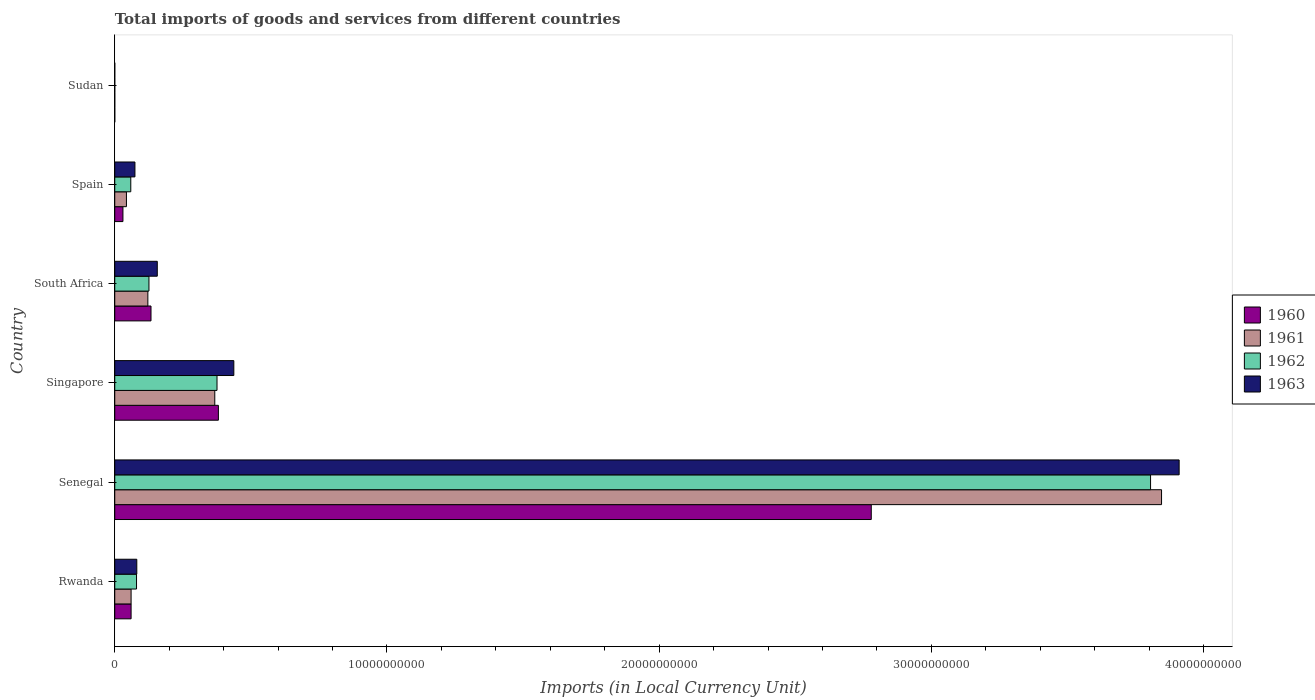How many different coloured bars are there?
Keep it short and to the point. 4. How many groups of bars are there?
Ensure brevity in your answer.  6. Are the number of bars per tick equal to the number of legend labels?
Make the answer very short. Yes. How many bars are there on the 4th tick from the top?
Keep it short and to the point. 4. What is the label of the 4th group of bars from the top?
Your answer should be compact. Singapore. In how many cases, is the number of bars for a given country not equal to the number of legend labels?
Your answer should be compact. 0. What is the Amount of goods and services imports in 1963 in Sudan?
Give a very brief answer. 8.49e+04. Across all countries, what is the maximum Amount of goods and services imports in 1963?
Your response must be concise. 3.91e+1. Across all countries, what is the minimum Amount of goods and services imports in 1963?
Ensure brevity in your answer.  8.49e+04. In which country was the Amount of goods and services imports in 1963 maximum?
Your answer should be very brief. Senegal. In which country was the Amount of goods and services imports in 1963 minimum?
Your answer should be very brief. Sudan. What is the total Amount of goods and services imports in 1962 in the graph?
Give a very brief answer. 4.45e+1. What is the difference between the Amount of goods and services imports in 1963 in Singapore and that in Sudan?
Your answer should be compact. 4.37e+09. What is the difference between the Amount of goods and services imports in 1962 in Rwanda and the Amount of goods and services imports in 1963 in Spain?
Your answer should be very brief. 5.85e+07. What is the average Amount of goods and services imports in 1962 per country?
Offer a terse response. 7.41e+09. What is the difference between the Amount of goods and services imports in 1963 and Amount of goods and services imports in 1962 in South Africa?
Give a very brief answer. 3.06e+08. In how many countries, is the Amount of goods and services imports in 1960 greater than 24000000000 LCU?
Provide a short and direct response. 1. What is the ratio of the Amount of goods and services imports in 1962 in Senegal to that in Spain?
Ensure brevity in your answer.  64.62. Is the difference between the Amount of goods and services imports in 1963 in Rwanda and South Africa greater than the difference between the Amount of goods and services imports in 1962 in Rwanda and South Africa?
Offer a terse response. No. What is the difference between the highest and the second highest Amount of goods and services imports in 1962?
Your answer should be compact. 3.43e+1. What is the difference between the highest and the lowest Amount of goods and services imports in 1961?
Make the answer very short. 3.85e+1. In how many countries, is the Amount of goods and services imports in 1961 greater than the average Amount of goods and services imports in 1961 taken over all countries?
Ensure brevity in your answer.  1. What does the 2nd bar from the bottom in Singapore represents?
Offer a terse response. 1961. How many bars are there?
Ensure brevity in your answer.  24. How many countries are there in the graph?
Your answer should be compact. 6. Does the graph contain any zero values?
Keep it short and to the point. No. Where does the legend appear in the graph?
Your answer should be very brief. Center right. How many legend labels are there?
Your answer should be compact. 4. What is the title of the graph?
Your response must be concise. Total imports of goods and services from different countries. Does "1961" appear as one of the legend labels in the graph?
Your answer should be compact. Yes. What is the label or title of the X-axis?
Your response must be concise. Imports (in Local Currency Unit). What is the label or title of the Y-axis?
Offer a terse response. Country. What is the Imports (in Local Currency Unit) of 1960 in Rwanda?
Your response must be concise. 6.00e+08. What is the Imports (in Local Currency Unit) of 1961 in Rwanda?
Keep it short and to the point. 6.00e+08. What is the Imports (in Local Currency Unit) of 1962 in Rwanda?
Provide a short and direct response. 8.00e+08. What is the Imports (in Local Currency Unit) in 1963 in Rwanda?
Your answer should be very brief. 8.10e+08. What is the Imports (in Local Currency Unit) in 1960 in Senegal?
Provide a short and direct response. 2.78e+1. What is the Imports (in Local Currency Unit) in 1961 in Senegal?
Provide a succinct answer. 3.85e+1. What is the Imports (in Local Currency Unit) in 1962 in Senegal?
Your response must be concise. 3.81e+1. What is the Imports (in Local Currency Unit) of 1963 in Senegal?
Give a very brief answer. 3.91e+1. What is the Imports (in Local Currency Unit) of 1960 in Singapore?
Ensure brevity in your answer.  3.81e+09. What is the Imports (in Local Currency Unit) in 1961 in Singapore?
Keep it short and to the point. 3.67e+09. What is the Imports (in Local Currency Unit) in 1962 in Singapore?
Your answer should be very brief. 3.76e+09. What is the Imports (in Local Currency Unit) of 1963 in Singapore?
Give a very brief answer. 4.37e+09. What is the Imports (in Local Currency Unit) of 1960 in South Africa?
Provide a short and direct response. 1.33e+09. What is the Imports (in Local Currency Unit) in 1961 in South Africa?
Provide a short and direct response. 1.22e+09. What is the Imports (in Local Currency Unit) in 1962 in South Africa?
Keep it short and to the point. 1.26e+09. What is the Imports (in Local Currency Unit) of 1963 in South Africa?
Your answer should be compact. 1.56e+09. What is the Imports (in Local Currency Unit) of 1960 in Spain?
Make the answer very short. 3.00e+08. What is the Imports (in Local Currency Unit) of 1961 in Spain?
Ensure brevity in your answer.  4.29e+08. What is the Imports (in Local Currency Unit) of 1962 in Spain?
Provide a succinct answer. 5.89e+08. What is the Imports (in Local Currency Unit) of 1963 in Spain?
Offer a very short reply. 7.42e+08. What is the Imports (in Local Currency Unit) in 1960 in Sudan?
Your answer should be compact. 5.10e+04. What is the Imports (in Local Currency Unit) of 1961 in Sudan?
Provide a short and direct response. 6.11e+04. What is the Imports (in Local Currency Unit) in 1962 in Sudan?
Your response must be concise. 6.96e+04. What is the Imports (in Local Currency Unit) of 1963 in Sudan?
Your answer should be very brief. 8.49e+04. Across all countries, what is the maximum Imports (in Local Currency Unit) of 1960?
Your answer should be very brief. 2.78e+1. Across all countries, what is the maximum Imports (in Local Currency Unit) of 1961?
Offer a terse response. 3.85e+1. Across all countries, what is the maximum Imports (in Local Currency Unit) of 1962?
Your response must be concise. 3.81e+1. Across all countries, what is the maximum Imports (in Local Currency Unit) of 1963?
Give a very brief answer. 3.91e+1. Across all countries, what is the minimum Imports (in Local Currency Unit) in 1960?
Your response must be concise. 5.10e+04. Across all countries, what is the minimum Imports (in Local Currency Unit) of 1961?
Offer a very short reply. 6.11e+04. Across all countries, what is the minimum Imports (in Local Currency Unit) of 1962?
Provide a succinct answer. 6.96e+04. Across all countries, what is the minimum Imports (in Local Currency Unit) in 1963?
Your response must be concise. 8.49e+04. What is the total Imports (in Local Currency Unit) in 1960 in the graph?
Offer a terse response. 3.38e+1. What is the total Imports (in Local Currency Unit) of 1961 in the graph?
Offer a terse response. 4.44e+1. What is the total Imports (in Local Currency Unit) of 1962 in the graph?
Your response must be concise. 4.45e+1. What is the total Imports (in Local Currency Unit) in 1963 in the graph?
Your answer should be very brief. 4.66e+1. What is the difference between the Imports (in Local Currency Unit) of 1960 in Rwanda and that in Senegal?
Provide a succinct answer. -2.72e+1. What is the difference between the Imports (in Local Currency Unit) in 1961 in Rwanda and that in Senegal?
Provide a succinct answer. -3.79e+1. What is the difference between the Imports (in Local Currency Unit) in 1962 in Rwanda and that in Senegal?
Ensure brevity in your answer.  -3.73e+1. What is the difference between the Imports (in Local Currency Unit) in 1963 in Rwanda and that in Senegal?
Your answer should be compact. -3.83e+1. What is the difference between the Imports (in Local Currency Unit) in 1960 in Rwanda and that in Singapore?
Make the answer very short. -3.21e+09. What is the difference between the Imports (in Local Currency Unit) in 1961 in Rwanda and that in Singapore?
Provide a succinct answer. -3.07e+09. What is the difference between the Imports (in Local Currency Unit) of 1962 in Rwanda and that in Singapore?
Offer a very short reply. -2.96e+09. What is the difference between the Imports (in Local Currency Unit) of 1963 in Rwanda and that in Singapore?
Offer a terse response. -3.56e+09. What is the difference between the Imports (in Local Currency Unit) of 1960 in Rwanda and that in South Africa?
Keep it short and to the point. -7.32e+08. What is the difference between the Imports (in Local Currency Unit) of 1961 in Rwanda and that in South Africa?
Your answer should be compact. -6.16e+08. What is the difference between the Imports (in Local Currency Unit) in 1962 in Rwanda and that in South Africa?
Your response must be concise. -4.57e+08. What is the difference between the Imports (in Local Currency Unit) of 1963 in Rwanda and that in South Africa?
Give a very brief answer. -7.52e+08. What is the difference between the Imports (in Local Currency Unit) of 1960 in Rwanda and that in Spain?
Provide a succinct answer. 3.00e+08. What is the difference between the Imports (in Local Currency Unit) of 1961 in Rwanda and that in Spain?
Your response must be concise. 1.71e+08. What is the difference between the Imports (in Local Currency Unit) of 1962 in Rwanda and that in Spain?
Give a very brief answer. 2.11e+08. What is the difference between the Imports (in Local Currency Unit) in 1963 in Rwanda and that in Spain?
Provide a succinct answer. 6.85e+07. What is the difference between the Imports (in Local Currency Unit) in 1960 in Rwanda and that in Sudan?
Offer a terse response. 6.00e+08. What is the difference between the Imports (in Local Currency Unit) in 1961 in Rwanda and that in Sudan?
Provide a succinct answer. 6.00e+08. What is the difference between the Imports (in Local Currency Unit) in 1962 in Rwanda and that in Sudan?
Your response must be concise. 8.00e+08. What is the difference between the Imports (in Local Currency Unit) of 1963 in Rwanda and that in Sudan?
Offer a very short reply. 8.10e+08. What is the difference between the Imports (in Local Currency Unit) in 1960 in Senegal and that in Singapore?
Give a very brief answer. 2.40e+1. What is the difference between the Imports (in Local Currency Unit) in 1961 in Senegal and that in Singapore?
Provide a short and direct response. 3.48e+1. What is the difference between the Imports (in Local Currency Unit) of 1962 in Senegal and that in Singapore?
Ensure brevity in your answer.  3.43e+1. What is the difference between the Imports (in Local Currency Unit) of 1963 in Senegal and that in Singapore?
Your answer should be very brief. 3.47e+1. What is the difference between the Imports (in Local Currency Unit) of 1960 in Senegal and that in South Africa?
Your answer should be compact. 2.65e+1. What is the difference between the Imports (in Local Currency Unit) in 1961 in Senegal and that in South Africa?
Make the answer very short. 3.72e+1. What is the difference between the Imports (in Local Currency Unit) in 1962 in Senegal and that in South Africa?
Keep it short and to the point. 3.68e+1. What is the difference between the Imports (in Local Currency Unit) in 1963 in Senegal and that in South Africa?
Make the answer very short. 3.75e+1. What is the difference between the Imports (in Local Currency Unit) of 1960 in Senegal and that in Spain?
Your response must be concise. 2.75e+1. What is the difference between the Imports (in Local Currency Unit) of 1961 in Senegal and that in Spain?
Ensure brevity in your answer.  3.80e+1. What is the difference between the Imports (in Local Currency Unit) in 1962 in Senegal and that in Spain?
Your answer should be compact. 3.75e+1. What is the difference between the Imports (in Local Currency Unit) of 1963 in Senegal and that in Spain?
Provide a succinct answer. 3.84e+1. What is the difference between the Imports (in Local Currency Unit) in 1960 in Senegal and that in Sudan?
Keep it short and to the point. 2.78e+1. What is the difference between the Imports (in Local Currency Unit) of 1961 in Senegal and that in Sudan?
Offer a very short reply. 3.85e+1. What is the difference between the Imports (in Local Currency Unit) in 1962 in Senegal and that in Sudan?
Ensure brevity in your answer.  3.81e+1. What is the difference between the Imports (in Local Currency Unit) of 1963 in Senegal and that in Sudan?
Give a very brief answer. 3.91e+1. What is the difference between the Imports (in Local Currency Unit) of 1960 in Singapore and that in South Africa?
Your answer should be very brief. 2.48e+09. What is the difference between the Imports (in Local Currency Unit) in 1961 in Singapore and that in South Africa?
Keep it short and to the point. 2.46e+09. What is the difference between the Imports (in Local Currency Unit) in 1962 in Singapore and that in South Africa?
Offer a terse response. 2.50e+09. What is the difference between the Imports (in Local Currency Unit) in 1963 in Singapore and that in South Africa?
Your answer should be compact. 2.81e+09. What is the difference between the Imports (in Local Currency Unit) in 1960 in Singapore and that in Spain?
Give a very brief answer. 3.51e+09. What is the difference between the Imports (in Local Currency Unit) in 1961 in Singapore and that in Spain?
Your answer should be very brief. 3.25e+09. What is the difference between the Imports (in Local Currency Unit) in 1962 in Singapore and that in Spain?
Your response must be concise. 3.17e+09. What is the difference between the Imports (in Local Currency Unit) in 1963 in Singapore and that in Spain?
Offer a terse response. 3.63e+09. What is the difference between the Imports (in Local Currency Unit) in 1960 in Singapore and that in Sudan?
Give a very brief answer. 3.81e+09. What is the difference between the Imports (in Local Currency Unit) of 1961 in Singapore and that in Sudan?
Your answer should be compact. 3.67e+09. What is the difference between the Imports (in Local Currency Unit) in 1962 in Singapore and that in Sudan?
Your answer should be compact. 3.76e+09. What is the difference between the Imports (in Local Currency Unit) of 1963 in Singapore and that in Sudan?
Provide a short and direct response. 4.37e+09. What is the difference between the Imports (in Local Currency Unit) in 1960 in South Africa and that in Spain?
Ensure brevity in your answer.  1.03e+09. What is the difference between the Imports (in Local Currency Unit) in 1961 in South Africa and that in Spain?
Keep it short and to the point. 7.87e+08. What is the difference between the Imports (in Local Currency Unit) of 1962 in South Africa and that in Spain?
Your response must be concise. 6.68e+08. What is the difference between the Imports (in Local Currency Unit) in 1963 in South Africa and that in Spain?
Ensure brevity in your answer.  8.21e+08. What is the difference between the Imports (in Local Currency Unit) of 1960 in South Africa and that in Sudan?
Provide a short and direct response. 1.33e+09. What is the difference between the Imports (in Local Currency Unit) of 1961 in South Africa and that in Sudan?
Provide a short and direct response. 1.22e+09. What is the difference between the Imports (in Local Currency Unit) in 1962 in South Africa and that in Sudan?
Your answer should be very brief. 1.26e+09. What is the difference between the Imports (in Local Currency Unit) in 1963 in South Africa and that in Sudan?
Offer a terse response. 1.56e+09. What is the difference between the Imports (in Local Currency Unit) in 1960 in Spain and that in Sudan?
Make the answer very short. 3.00e+08. What is the difference between the Imports (in Local Currency Unit) of 1961 in Spain and that in Sudan?
Make the answer very short. 4.29e+08. What is the difference between the Imports (in Local Currency Unit) of 1962 in Spain and that in Sudan?
Provide a succinct answer. 5.89e+08. What is the difference between the Imports (in Local Currency Unit) of 1963 in Spain and that in Sudan?
Make the answer very short. 7.41e+08. What is the difference between the Imports (in Local Currency Unit) in 1960 in Rwanda and the Imports (in Local Currency Unit) in 1961 in Senegal?
Your answer should be very brief. -3.79e+1. What is the difference between the Imports (in Local Currency Unit) of 1960 in Rwanda and the Imports (in Local Currency Unit) of 1962 in Senegal?
Provide a short and direct response. -3.75e+1. What is the difference between the Imports (in Local Currency Unit) in 1960 in Rwanda and the Imports (in Local Currency Unit) in 1963 in Senegal?
Your response must be concise. -3.85e+1. What is the difference between the Imports (in Local Currency Unit) of 1961 in Rwanda and the Imports (in Local Currency Unit) of 1962 in Senegal?
Your answer should be very brief. -3.75e+1. What is the difference between the Imports (in Local Currency Unit) of 1961 in Rwanda and the Imports (in Local Currency Unit) of 1963 in Senegal?
Ensure brevity in your answer.  -3.85e+1. What is the difference between the Imports (in Local Currency Unit) of 1962 in Rwanda and the Imports (in Local Currency Unit) of 1963 in Senegal?
Make the answer very short. -3.83e+1. What is the difference between the Imports (in Local Currency Unit) in 1960 in Rwanda and the Imports (in Local Currency Unit) in 1961 in Singapore?
Offer a terse response. -3.07e+09. What is the difference between the Imports (in Local Currency Unit) in 1960 in Rwanda and the Imports (in Local Currency Unit) in 1962 in Singapore?
Ensure brevity in your answer.  -3.16e+09. What is the difference between the Imports (in Local Currency Unit) in 1960 in Rwanda and the Imports (in Local Currency Unit) in 1963 in Singapore?
Provide a succinct answer. -3.77e+09. What is the difference between the Imports (in Local Currency Unit) in 1961 in Rwanda and the Imports (in Local Currency Unit) in 1962 in Singapore?
Offer a very short reply. -3.16e+09. What is the difference between the Imports (in Local Currency Unit) in 1961 in Rwanda and the Imports (in Local Currency Unit) in 1963 in Singapore?
Offer a terse response. -3.77e+09. What is the difference between the Imports (in Local Currency Unit) of 1962 in Rwanda and the Imports (in Local Currency Unit) of 1963 in Singapore?
Offer a very short reply. -3.57e+09. What is the difference between the Imports (in Local Currency Unit) of 1960 in Rwanda and the Imports (in Local Currency Unit) of 1961 in South Africa?
Ensure brevity in your answer.  -6.16e+08. What is the difference between the Imports (in Local Currency Unit) in 1960 in Rwanda and the Imports (in Local Currency Unit) in 1962 in South Africa?
Make the answer very short. -6.57e+08. What is the difference between the Imports (in Local Currency Unit) of 1960 in Rwanda and the Imports (in Local Currency Unit) of 1963 in South Africa?
Provide a succinct answer. -9.62e+08. What is the difference between the Imports (in Local Currency Unit) of 1961 in Rwanda and the Imports (in Local Currency Unit) of 1962 in South Africa?
Provide a short and direct response. -6.57e+08. What is the difference between the Imports (in Local Currency Unit) in 1961 in Rwanda and the Imports (in Local Currency Unit) in 1963 in South Africa?
Offer a very short reply. -9.62e+08. What is the difference between the Imports (in Local Currency Unit) in 1962 in Rwanda and the Imports (in Local Currency Unit) in 1963 in South Africa?
Your answer should be compact. -7.62e+08. What is the difference between the Imports (in Local Currency Unit) of 1960 in Rwanda and the Imports (in Local Currency Unit) of 1961 in Spain?
Provide a succinct answer. 1.71e+08. What is the difference between the Imports (in Local Currency Unit) in 1960 in Rwanda and the Imports (in Local Currency Unit) in 1962 in Spain?
Provide a succinct answer. 1.11e+07. What is the difference between the Imports (in Local Currency Unit) in 1960 in Rwanda and the Imports (in Local Currency Unit) in 1963 in Spain?
Your response must be concise. -1.42e+08. What is the difference between the Imports (in Local Currency Unit) of 1961 in Rwanda and the Imports (in Local Currency Unit) of 1962 in Spain?
Provide a succinct answer. 1.11e+07. What is the difference between the Imports (in Local Currency Unit) in 1961 in Rwanda and the Imports (in Local Currency Unit) in 1963 in Spain?
Offer a terse response. -1.42e+08. What is the difference between the Imports (in Local Currency Unit) of 1962 in Rwanda and the Imports (in Local Currency Unit) of 1963 in Spain?
Provide a short and direct response. 5.85e+07. What is the difference between the Imports (in Local Currency Unit) of 1960 in Rwanda and the Imports (in Local Currency Unit) of 1961 in Sudan?
Give a very brief answer. 6.00e+08. What is the difference between the Imports (in Local Currency Unit) in 1960 in Rwanda and the Imports (in Local Currency Unit) in 1962 in Sudan?
Your response must be concise. 6.00e+08. What is the difference between the Imports (in Local Currency Unit) in 1960 in Rwanda and the Imports (in Local Currency Unit) in 1963 in Sudan?
Provide a short and direct response. 6.00e+08. What is the difference between the Imports (in Local Currency Unit) in 1961 in Rwanda and the Imports (in Local Currency Unit) in 1962 in Sudan?
Offer a terse response. 6.00e+08. What is the difference between the Imports (in Local Currency Unit) in 1961 in Rwanda and the Imports (in Local Currency Unit) in 1963 in Sudan?
Offer a terse response. 6.00e+08. What is the difference between the Imports (in Local Currency Unit) of 1962 in Rwanda and the Imports (in Local Currency Unit) of 1963 in Sudan?
Provide a short and direct response. 8.00e+08. What is the difference between the Imports (in Local Currency Unit) of 1960 in Senegal and the Imports (in Local Currency Unit) of 1961 in Singapore?
Your response must be concise. 2.41e+1. What is the difference between the Imports (in Local Currency Unit) in 1960 in Senegal and the Imports (in Local Currency Unit) in 1962 in Singapore?
Your answer should be very brief. 2.40e+1. What is the difference between the Imports (in Local Currency Unit) in 1960 in Senegal and the Imports (in Local Currency Unit) in 1963 in Singapore?
Provide a short and direct response. 2.34e+1. What is the difference between the Imports (in Local Currency Unit) of 1961 in Senegal and the Imports (in Local Currency Unit) of 1962 in Singapore?
Offer a very short reply. 3.47e+1. What is the difference between the Imports (in Local Currency Unit) of 1961 in Senegal and the Imports (in Local Currency Unit) of 1963 in Singapore?
Your answer should be very brief. 3.41e+1. What is the difference between the Imports (in Local Currency Unit) in 1962 in Senegal and the Imports (in Local Currency Unit) in 1963 in Singapore?
Make the answer very short. 3.37e+1. What is the difference between the Imports (in Local Currency Unit) of 1960 in Senegal and the Imports (in Local Currency Unit) of 1961 in South Africa?
Provide a short and direct response. 2.66e+1. What is the difference between the Imports (in Local Currency Unit) of 1960 in Senegal and the Imports (in Local Currency Unit) of 1962 in South Africa?
Provide a succinct answer. 2.65e+1. What is the difference between the Imports (in Local Currency Unit) of 1960 in Senegal and the Imports (in Local Currency Unit) of 1963 in South Africa?
Offer a very short reply. 2.62e+1. What is the difference between the Imports (in Local Currency Unit) of 1961 in Senegal and the Imports (in Local Currency Unit) of 1962 in South Africa?
Your answer should be very brief. 3.72e+1. What is the difference between the Imports (in Local Currency Unit) in 1961 in Senegal and the Imports (in Local Currency Unit) in 1963 in South Africa?
Make the answer very short. 3.69e+1. What is the difference between the Imports (in Local Currency Unit) of 1962 in Senegal and the Imports (in Local Currency Unit) of 1963 in South Africa?
Keep it short and to the point. 3.65e+1. What is the difference between the Imports (in Local Currency Unit) in 1960 in Senegal and the Imports (in Local Currency Unit) in 1961 in Spain?
Provide a succinct answer. 2.74e+1. What is the difference between the Imports (in Local Currency Unit) of 1960 in Senegal and the Imports (in Local Currency Unit) of 1962 in Spain?
Offer a very short reply. 2.72e+1. What is the difference between the Imports (in Local Currency Unit) of 1960 in Senegal and the Imports (in Local Currency Unit) of 1963 in Spain?
Your answer should be very brief. 2.71e+1. What is the difference between the Imports (in Local Currency Unit) of 1961 in Senegal and the Imports (in Local Currency Unit) of 1962 in Spain?
Make the answer very short. 3.79e+1. What is the difference between the Imports (in Local Currency Unit) of 1961 in Senegal and the Imports (in Local Currency Unit) of 1963 in Spain?
Provide a succinct answer. 3.77e+1. What is the difference between the Imports (in Local Currency Unit) in 1962 in Senegal and the Imports (in Local Currency Unit) in 1963 in Spain?
Keep it short and to the point. 3.73e+1. What is the difference between the Imports (in Local Currency Unit) of 1960 in Senegal and the Imports (in Local Currency Unit) of 1961 in Sudan?
Your answer should be compact. 2.78e+1. What is the difference between the Imports (in Local Currency Unit) in 1960 in Senegal and the Imports (in Local Currency Unit) in 1962 in Sudan?
Your answer should be very brief. 2.78e+1. What is the difference between the Imports (in Local Currency Unit) in 1960 in Senegal and the Imports (in Local Currency Unit) in 1963 in Sudan?
Give a very brief answer. 2.78e+1. What is the difference between the Imports (in Local Currency Unit) of 1961 in Senegal and the Imports (in Local Currency Unit) of 1962 in Sudan?
Your answer should be compact. 3.85e+1. What is the difference between the Imports (in Local Currency Unit) in 1961 in Senegal and the Imports (in Local Currency Unit) in 1963 in Sudan?
Your answer should be compact. 3.85e+1. What is the difference between the Imports (in Local Currency Unit) in 1962 in Senegal and the Imports (in Local Currency Unit) in 1963 in Sudan?
Your answer should be very brief. 3.81e+1. What is the difference between the Imports (in Local Currency Unit) of 1960 in Singapore and the Imports (in Local Currency Unit) of 1961 in South Africa?
Provide a short and direct response. 2.59e+09. What is the difference between the Imports (in Local Currency Unit) in 1960 in Singapore and the Imports (in Local Currency Unit) in 1962 in South Africa?
Provide a succinct answer. 2.55e+09. What is the difference between the Imports (in Local Currency Unit) in 1960 in Singapore and the Imports (in Local Currency Unit) in 1963 in South Africa?
Your answer should be compact. 2.25e+09. What is the difference between the Imports (in Local Currency Unit) in 1961 in Singapore and the Imports (in Local Currency Unit) in 1962 in South Africa?
Give a very brief answer. 2.42e+09. What is the difference between the Imports (in Local Currency Unit) in 1961 in Singapore and the Imports (in Local Currency Unit) in 1963 in South Africa?
Keep it short and to the point. 2.11e+09. What is the difference between the Imports (in Local Currency Unit) of 1962 in Singapore and the Imports (in Local Currency Unit) of 1963 in South Africa?
Provide a succinct answer. 2.19e+09. What is the difference between the Imports (in Local Currency Unit) in 1960 in Singapore and the Imports (in Local Currency Unit) in 1961 in Spain?
Your response must be concise. 3.38e+09. What is the difference between the Imports (in Local Currency Unit) of 1960 in Singapore and the Imports (in Local Currency Unit) of 1962 in Spain?
Your response must be concise. 3.22e+09. What is the difference between the Imports (in Local Currency Unit) of 1960 in Singapore and the Imports (in Local Currency Unit) of 1963 in Spain?
Ensure brevity in your answer.  3.07e+09. What is the difference between the Imports (in Local Currency Unit) in 1961 in Singapore and the Imports (in Local Currency Unit) in 1962 in Spain?
Ensure brevity in your answer.  3.09e+09. What is the difference between the Imports (in Local Currency Unit) of 1961 in Singapore and the Imports (in Local Currency Unit) of 1963 in Spain?
Your answer should be very brief. 2.93e+09. What is the difference between the Imports (in Local Currency Unit) of 1962 in Singapore and the Imports (in Local Currency Unit) of 1963 in Spain?
Offer a very short reply. 3.02e+09. What is the difference between the Imports (in Local Currency Unit) of 1960 in Singapore and the Imports (in Local Currency Unit) of 1961 in Sudan?
Provide a short and direct response. 3.81e+09. What is the difference between the Imports (in Local Currency Unit) in 1960 in Singapore and the Imports (in Local Currency Unit) in 1962 in Sudan?
Give a very brief answer. 3.81e+09. What is the difference between the Imports (in Local Currency Unit) of 1960 in Singapore and the Imports (in Local Currency Unit) of 1963 in Sudan?
Your answer should be very brief. 3.81e+09. What is the difference between the Imports (in Local Currency Unit) in 1961 in Singapore and the Imports (in Local Currency Unit) in 1962 in Sudan?
Your answer should be very brief. 3.67e+09. What is the difference between the Imports (in Local Currency Unit) of 1961 in Singapore and the Imports (in Local Currency Unit) of 1963 in Sudan?
Offer a terse response. 3.67e+09. What is the difference between the Imports (in Local Currency Unit) of 1962 in Singapore and the Imports (in Local Currency Unit) of 1963 in Sudan?
Provide a short and direct response. 3.76e+09. What is the difference between the Imports (in Local Currency Unit) of 1960 in South Africa and the Imports (in Local Currency Unit) of 1961 in Spain?
Your answer should be very brief. 9.03e+08. What is the difference between the Imports (in Local Currency Unit) in 1960 in South Africa and the Imports (in Local Currency Unit) in 1962 in Spain?
Give a very brief answer. 7.43e+08. What is the difference between the Imports (in Local Currency Unit) of 1960 in South Africa and the Imports (in Local Currency Unit) of 1963 in Spain?
Offer a terse response. 5.90e+08. What is the difference between the Imports (in Local Currency Unit) of 1961 in South Africa and the Imports (in Local Currency Unit) of 1962 in Spain?
Your answer should be very brief. 6.27e+08. What is the difference between the Imports (in Local Currency Unit) of 1961 in South Africa and the Imports (in Local Currency Unit) of 1963 in Spain?
Provide a short and direct response. 4.74e+08. What is the difference between the Imports (in Local Currency Unit) of 1962 in South Africa and the Imports (in Local Currency Unit) of 1963 in Spain?
Provide a succinct answer. 5.15e+08. What is the difference between the Imports (in Local Currency Unit) in 1960 in South Africa and the Imports (in Local Currency Unit) in 1961 in Sudan?
Provide a short and direct response. 1.33e+09. What is the difference between the Imports (in Local Currency Unit) in 1960 in South Africa and the Imports (in Local Currency Unit) in 1962 in Sudan?
Make the answer very short. 1.33e+09. What is the difference between the Imports (in Local Currency Unit) in 1960 in South Africa and the Imports (in Local Currency Unit) in 1963 in Sudan?
Offer a terse response. 1.33e+09. What is the difference between the Imports (in Local Currency Unit) of 1961 in South Africa and the Imports (in Local Currency Unit) of 1962 in Sudan?
Give a very brief answer. 1.22e+09. What is the difference between the Imports (in Local Currency Unit) of 1961 in South Africa and the Imports (in Local Currency Unit) of 1963 in Sudan?
Keep it short and to the point. 1.22e+09. What is the difference between the Imports (in Local Currency Unit) in 1962 in South Africa and the Imports (in Local Currency Unit) in 1963 in Sudan?
Give a very brief answer. 1.26e+09. What is the difference between the Imports (in Local Currency Unit) of 1960 in Spain and the Imports (in Local Currency Unit) of 1961 in Sudan?
Offer a very short reply. 3.00e+08. What is the difference between the Imports (in Local Currency Unit) of 1960 in Spain and the Imports (in Local Currency Unit) of 1962 in Sudan?
Keep it short and to the point. 3.00e+08. What is the difference between the Imports (in Local Currency Unit) in 1960 in Spain and the Imports (in Local Currency Unit) in 1963 in Sudan?
Make the answer very short. 3.00e+08. What is the difference between the Imports (in Local Currency Unit) of 1961 in Spain and the Imports (in Local Currency Unit) of 1962 in Sudan?
Provide a short and direct response. 4.29e+08. What is the difference between the Imports (in Local Currency Unit) of 1961 in Spain and the Imports (in Local Currency Unit) of 1963 in Sudan?
Keep it short and to the point. 4.29e+08. What is the difference between the Imports (in Local Currency Unit) in 1962 in Spain and the Imports (in Local Currency Unit) in 1963 in Sudan?
Provide a succinct answer. 5.89e+08. What is the average Imports (in Local Currency Unit) of 1960 per country?
Offer a very short reply. 5.64e+09. What is the average Imports (in Local Currency Unit) of 1961 per country?
Offer a very short reply. 7.40e+09. What is the average Imports (in Local Currency Unit) in 1962 per country?
Keep it short and to the point. 7.41e+09. What is the average Imports (in Local Currency Unit) of 1963 per country?
Offer a very short reply. 7.77e+09. What is the difference between the Imports (in Local Currency Unit) of 1960 and Imports (in Local Currency Unit) of 1962 in Rwanda?
Your answer should be compact. -2.00e+08. What is the difference between the Imports (in Local Currency Unit) of 1960 and Imports (in Local Currency Unit) of 1963 in Rwanda?
Give a very brief answer. -2.10e+08. What is the difference between the Imports (in Local Currency Unit) of 1961 and Imports (in Local Currency Unit) of 1962 in Rwanda?
Give a very brief answer. -2.00e+08. What is the difference between the Imports (in Local Currency Unit) of 1961 and Imports (in Local Currency Unit) of 1963 in Rwanda?
Keep it short and to the point. -2.10e+08. What is the difference between the Imports (in Local Currency Unit) of 1962 and Imports (in Local Currency Unit) of 1963 in Rwanda?
Give a very brief answer. -1.00e+07. What is the difference between the Imports (in Local Currency Unit) of 1960 and Imports (in Local Currency Unit) of 1961 in Senegal?
Provide a succinct answer. -1.07e+1. What is the difference between the Imports (in Local Currency Unit) of 1960 and Imports (in Local Currency Unit) of 1962 in Senegal?
Provide a succinct answer. -1.03e+1. What is the difference between the Imports (in Local Currency Unit) of 1960 and Imports (in Local Currency Unit) of 1963 in Senegal?
Give a very brief answer. -1.13e+1. What is the difference between the Imports (in Local Currency Unit) of 1961 and Imports (in Local Currency Unit) of 1962 in Senegal?
Your answer should be very brief. 4.04e+08. What is the difference between the Imports (in Local Currency Unit) of 1961 and Imports (in Local Currency Unit) of 1963 in Senegal?
Provide a succinct answer. -6.46e+08. What is the difference between the Imports (in Local Currency Unit) in 1962 and Imports (in Local Currency Unit) in 1963 in Senegal?
Your response must be concise. -1.05e+09. What is the difference between the Imports (in Local Currency Unit) of 1960 and Imports (in Local Currency Unit) of 1961 in Singapore?
Your response must be concise. 1.33e+08. What is the difference between the Imports (in Local Currency Unit) in 1960 and Imports (in Local Currency Unit) in 1962 in Singapore?
Your answer should be compact. 5.08e+07. What is the difference between the Imports (in Local Currency Unit) of 1960 and Imports (in Local Currency Unit) of 1963 in Singapore?
Make the answer very short. -5.67e+08. What is the difference between the Imports (in Local Currency Unit) in 1961 and Imports (in Local Currency Unit) in 1962 in Singapore?
Offer a very short reply. -8.22e+07. What is the difference between the Imports (in Local Currency Unit) in 1961 and Imports (in Local Currency Unit) in 1963 in Singapore?
Provide a succinct answer. -7.00e+08. What is the difference between the Imports (in Local Currency Unit) in 1962 and Imports (in Local Currency Unit) in 1963 in Singapore?
Give a very brief answer. -6.18e+08. What is the difference between the Imports (in Local Currency Unit) of 1960 and Imports (in Local Currency Unit) of 1961 in South Africa?
Offer a very short reply. 1.16e+08. What is the difference between the Imports (in Local Currency Unit) in 1960 and Imports (in Local Currency Unit) in 1962 in South Africa?
Your response must be concise. 7.51e+07. What is the difference between the Imports (in Local Currency Unit) of 1960 and Imports (in Local Currency Unit) of 1963 in South Africa?
Keep it short and to the point. -2.30e+08. What is the difference between the Imports (in Local Currency Unit) in 1961 and Imports (in Local Currency Unit) in 1962 in South Africa?
Provide a succinct answer. -4.06e+07. What is the difference between the Imports (in Local Currency Unit) of 1961 and Imports (in Local Currency Unit) of 1963 in South Africa?
Ensure brevity in your answer.  -3.46e+08. What is the difference between the Imports (in Local Currency Unit) in 1962 and Imports (in Local Currency Unit) in 1963 in South Africa?
Your response must be concise. -3.06e+08. What is the difference between the Imports (in Local Currency Unit) in 1960 and Imports (in Local Currency Unit) in 1961 in Spain?
Give a very brief answer. -1.29e+08. What is the difference between the Imports (in Local Currency Unit) of 1960 and Imports (in Local Currency Unit) of 1962 in Spain?
Provide a succinct answer. -2.88e+08. What is the difference between the Imports (in Local Currency Unit) of 1960 and Imports (in Local Currency Unit) of 1963 in Spain?
Offer a very short reply. -4.41e+08. What is the difference between the Imports (in Local Currency Unit) in 1961 and Imports (in Local Currency Unit) in 1962 in Spain?
Your response must be concise. -1.60e+08. What is the difference between the Imports (in Local Currency Unit) in 1961 and Imports (in Local Currency Unit) in 1963 in Spain?
Offer a terse response. -3.12e+08. What is the difference between the Imports (in Local Currency Unit) in 1962 and Imports (in Local Currency Unit) in 1963 in Spain?
Provide a short and direct response. -1.53e+08. What is the difference between the Imports (in Local Currency Unit) of 1960 and Imports (in Local Currency Unit) of 1961 in Sudan?
Provide a succinct answer. -1.01e+04. What is the difference between the Imports (in Local Currency Unit) of 1960 and Imports (in Local Currency Unit) of 1962 in Sudan?
Keep it short and to the point. -1.86e+04. What is the difference between the Imports (in Local Currency Unit) in 1960 and Imports (in Local Currency Unit) in 1963 in Sudan?
Provide a succinct answer. -3.39e+04. What is the difference between the Imports (in Local Currency Unit) of 1961 and Imports (in Local Currency Unit) of 1962 in Sudan?
Keep it short and to the point. -8500. What is the difference between the Imports (in Local Currency Unit) of 1961 and Imports (in Local Currency Unit) of 1963 in Sudan?
Your response must be concise. -2.38e+04. What is the difference between the Imports (in Local Currency Unit) of 1962 and Imports (in Local Currency Unit) of 1963 in Sudan?
Keep it short and to the point. -1.53e+04. What is the ratio of the Imports (in Local Currency Unit) of 1960 in Rwanda to that in Senegal?
Offer a very short reply. 0.02. What is the ratio of the Imports (in Local Currency Unit) of 1961 in Rwanda to that in Senegal?
Your response must be concise. 0.02. What is the ratio of the Imports (in Local Currency Unit) of 1962 in Rwanda to that in Senegal?
Your answer should be compact. 0.02. What is the ratio of the Imports (in Local Currency Unit) of 1963 in Rwanda to that in Senegal?
Your answer should be very brief. 0.02. What is the ratio of the Imports (in Local Currency Unit) in 1960 in Rwanda to that in Singapore?
Provide a short and direct response. 0.16. What is the ratio of the Imports (in Local Currency Unit) in 1961 in Rwanda to that in Singapore?
Your answer should be compact. 0.16. What is the ratio of the Imports (in Local Currency Unit) of 1962 in Rwanda to that in Singapore?
Your answer should be very brief. 0.21. What is the ratio of the Imports (in Local Currency Unit) in 1963 in Rwanda to that in Singapore?
Keep it short and to the point. 0.19. What is the ratio of the Imports (in Local Currency Unit) of 1960 in Rwanda to that in South Africa?
Your response must be concise. 0.45. What is the ratio of the Imports (in Local Currency Unit) in 1961 in Rwanda to that in South Africa?
Offer a very short reply. 0.49. What is the ratio of the Imports (in Local Currency Unit) of 1962 in Rwanda to that in South Africa?
Your answer should be very brief. 0.64. What is the ratio of the Imports (in Local Currency Unit) in 1963 in Rwanda to that in South Africa?
Keep it short and to the point. 0.52. What is the ratio of the Imports (in Local Currency Unit) of 1960 in Rwanda to that in Spain?
Provide a succinct answer. 2. What is the ratio of the Imports (in Local Currency Unit) of 1961 in Rwanda to that in Spain?
Offer a very short reply. 1.4. What is the ratio of the Imports (in Local Currency Unit) of 1962 in Rwanda to that in Spain?
Offer a terse response. 1.36. What is the ratio of the Imports (in Local Currency Unit) in 1963 in Rwanda to that in Spain?
Ensure brevity in your answer.  1.09. What is the ratio of the Imports (in Local Currency Unit) in 1960 in Rwanda to that in Sudan?
Offer a very short reply. 1.18e+04. What is the ratio of the Imports (in Local Currency Unit) in 1961 in Rwanda to that in Sudan?
Give a very brief answer. 9819.97. What is the ratio of the Imports (in Local Currency Unit) in 1962 in Rwanda to that in Sudan?
Make the answer very short. 1.15e+04. What is the ratio of the Imports (in Local Currency Unit) of 1963 in Rwanda to that in Sudan?
Offer a very short reply. 9540.64. What is the ratio of the Imports (in Local Currency Unit) of 1960 in Senegal to that in Singapore?
Make the answer very short. 7.3. What is the ratio of the Imports (in Local Currency Unit) of 1961 in Senegal to that in Singapore?
Give a very brief answer. 10.47. What is the ratio of the Imports (in Local Currency Unit) of 1962 in Senegal to that in Singapore?
Provide a short and direct response. 10.13. What is the ratio of the Imports (in Local Currency Unit) in 1963 in Senegal to that in Singapore?
Ensure brevity in your answer.  8.94. What is the ratio of the Imports (in Local Currency Unit) in 1960 in Senegal to that in South Africa?
Keep it short and to the point. 20.87. What is the ratio of the Imports (in Local Currency Unit) in 1961 in Senegal to that in South Africa?
Your answer should be very brief. 31.63. What is the ratio of the Imports (in Local Currency Unit) of 1962 in Senegal to that in South Africa?
Your answer should be compact. 30.28. What is the ratio of the Imports (in Local Currency Unit) of 1963 in Senegal to that in South Africa?
Offer a terse response. 25.03. What is the ratio of the Imports (in Local Currency Unit) of 1960 in Senegal to that in Spain?
Offer a terse response. 92.51. What is the ratio of the Imports (in Local Currency Unit) of 1961 in Senegal to that in Spain?
Your response must be concise. 89.62. What is the ratio of the Imports (in Local Currency Unit) in 1962 in Senegal to that in Spain?
Keep it short and to the point. 64.62. What is the ratio of the Imports (in Local Currency Unit) of 1963 in Senegal to that in Spain?
Ensure brevity in your answer.  52.73. What is the ratio of the Imports (in Local Currency Unit) of 1960 in Senegal to that in Sudan?
Provide a succinct answer. 5.45e+05. What is the ratio of the Imports (in Local Currency Unit) of 1961 in Senegal to that in Sudan?
Offer a very short reply. 6.29e+05. What is the ratio of the Imports (in Local Currency Unit) of 1962 in Senegal to that in Sudan?
Keep it short and to the point. 5.47e+05. What is the ratio of the Imports (in Local Currency Unit) of 1963 in Senegal to that in Sudan?
Ensure brevity in your answer.  4.61e+05. What is the ratio of the Imports (in Local Currency Unit) in 1960 in Singapore to that in South Africa?
Ensure brevity in your answer.  2.86. What is the ratio of the Imports (in Local Currency Unit) in 1961 in Singapore to that in South Africa?
Your answer should be very brief. 3.02. What is the ratio of the Imports (in Local Currency Unit) in 1962 in Singapore to that in South Africa?
Your answer should be very brief. 2.99. What is the ratio of the Imports (in Local Currency Unit) in 1963 in Singapore to that in South Africa?
Your answer should be very brief. 2.8. What is the ratio of the Imports (in Local Currency Unit) of 1960 in Singapore to that in Spain?
Keep it short and to the point. 12.67. What is the ratio of the Imports (in Local Currency Unit) of 1961 in Singapore to that in Spain?
Make the answer very short. 8.56. What is the ratio of the Imports (in Local Currency Unit) of 1962 in Singapore to that in Spain?
Offer a terse response. 6.38. What is the ratio of the Imports (in Local Currency Unit) in 1963 in Singapore to that in Spain?
Give a very brief answer. 5.9. What is the ratio of the Imports (in Local Currency Unit) of 1960 in Singapore to that in Sudan?
Your answer should be very brief. 7.47e+04. What is the ratio of the Imports (in Local Currency Unit) of 1961 in Singapore to that in Sudan?
Provide a short and direct response. 6.01e+04. What is the ratio of the Imports (in Local Currency Unit) in 1962 in Singapore to that in Sudan?
Provide a succinct answer. 5.40e+04. What is the ratio of the Imports (in Local Currency Unit) in 1963 in Singapore to that in Sudan?
Your answer should be very brief. 5.15e+04. What is the ratio of the Imports (in Local Currency Unit) of 1960 in South Africa to that in Spain?
Ensure brevity in your answer.  4.43. What is the ratio of the Imports (in Local Currency Unit) in 1961 in South Africa to that in Spain?
Make the answer very short. 2.83. What is the ratio of the Imports (in Local Currency Unit) of 1962 in South Africa to that in Spain?
Keep it short and to the point. 2.13. What is the ratio of the Imports (in Local Currency Unit) in 1963 in South Africa to that in Spain?
Your response must be concise. 2.11. What is the ratio of the Imports (in Local Currency Unit) of 1960 in South Africa to that in Sudan?
Provide a succinct answer. 2.61e+04. What is the ratio of the Imports (in Local Currency Unit) of 1961 in South Africa to that in Sudan?
Provide a short and direct response. 1.99e+04. What is the ratio of the Imports (in Local Currency Unit) of 1962 in South Africa to that in Sudan?
Offer a terse response. 1.81e+04. What is the ratio of the Imports (in Local Currency Unit) of 1963 in South Africa to that in Sudan?
Provide a succinct answer. 1.84e+04. What is the ratio of the Imports (in Local Currency Unit) in 1960 in Spain to that in Sudan?
Your answer should be very brief. 5890.88. What is the ratio of the Imports (in Local Currency Unit) in 1961 in Spain to that in Sudan?
Provide a short and direct response. 7023.03. What is the ratio of the Imports (in Local Currency Unit) in 1962 in Spain to that in Sudan?
Ensure brevity in your answer.  8461.21. What is the ratio of the Imports (in Local Currency Unit) in 1963 in Spain to that in Sudan?
Provide a succinct answer. 8733.94. What is the difference between the highest and the second highest Imports (in Local Currency Unit) of 1960?
Offer a terse response. 2.40e+1. What is the difference between the highest and the second highest Imports (in Local Currency Unit) in 1961?
Offer a terse response. 3.48e+1. What is the difference between the highest and the second highest Imports (in Local Currency Unit) of 1962?
Keep it short and to the point. 3.43e+1. What is the difference between the highest and the second highest Imports (in Local Currency Unit) of 1963?
Keep it short and to the point. 3.47e+1. What is the difference between the highest and the lowest Imports (in Local Currency Unit) of 1960?
Keep it short and to the point. 2.78e+1. What is the difference between the highest and the lowest Imports (in Local Currency Unit) in 1961?
Your response must be concise. 3.85e+1. What is the difference between the highest and the lowest Imports (in Local Currency Unit) of 1962?
Provide a succinct answer. 3.81e+1. What is the difference between the highest and the lowest Imports (in Local Currency Unit) of 1963?
Give a very brief answer. 3.91e+1. 